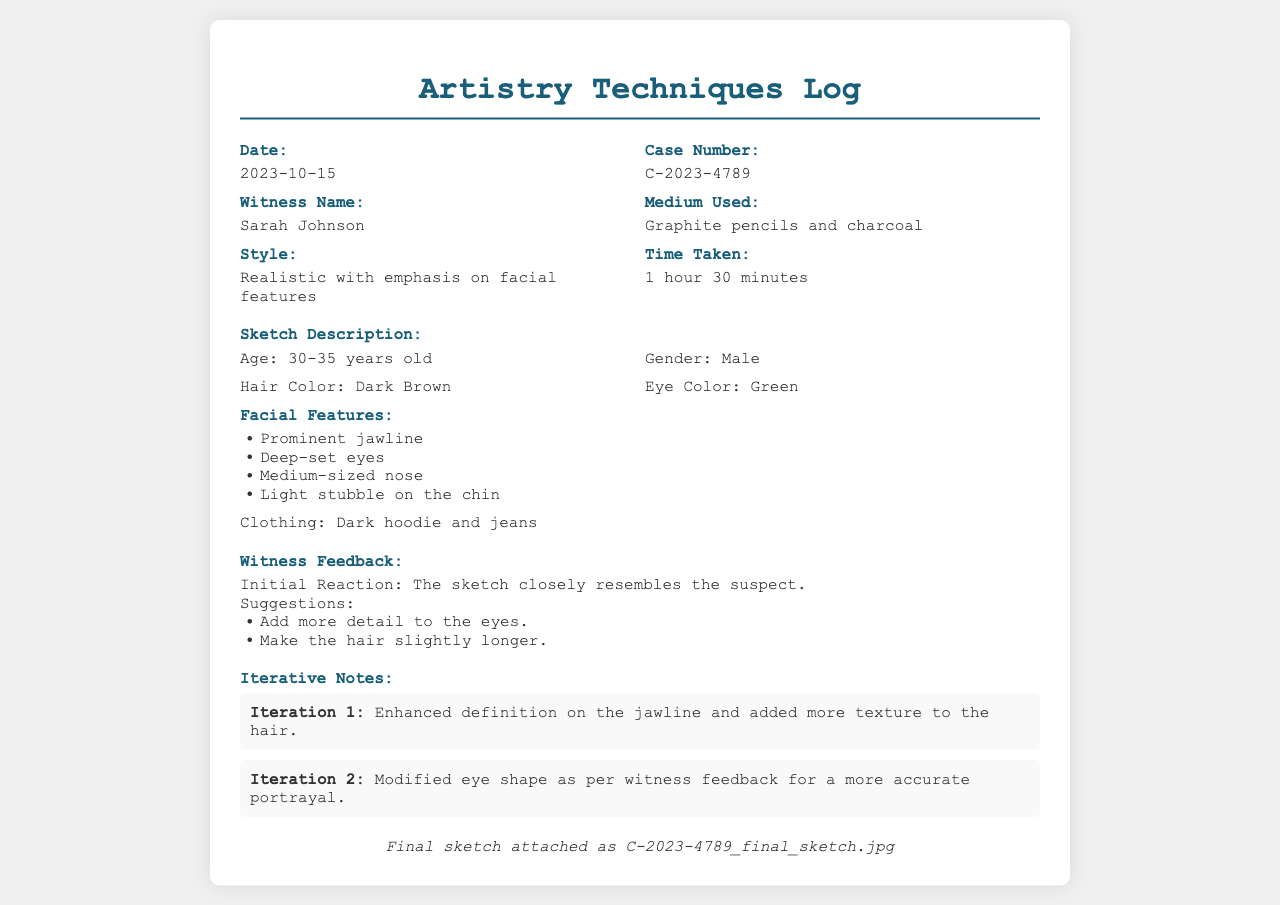What is the date of the sketch? The date is mentioned at the top of the document under "Date."
Answer: 2023-10-15 Who is the witness? The witness's name is provided in the section titled "Witness Name."
Answer: Sarah Johnson What medium was used for the sketch? The medium is listed in the "Medium Used" section.
Answer: Graphite pencils and charcoal How many minutes did it take to create the sketch? The time taken is noted in the "Time Taken" section.
Answer: 90 minutes What is the age range of the suspect? The age range is described in the sketch description.
Answer: 30-35 years old What clothing is the suspect wearing? The clothing description is provided at the end of the sketch description.
Answer: Dark hoodie and jeans What was the initial reaction of the witness? The initial reaction is indicated in the "Witness Feedback" section.
Answer: The sketch closely resembles the suspect What suggestion was made regarding the hair? The suggestion is mentioned under "Suggestions" in the "Witness Feedback" section.
Answer: Make the hair slightly longer What was the focus of Iteration 1? The changes made in Iteration 1 are detailed in the "Iterative Notes" section.
Answer: Enhanced definition on the jawline and added more texture to the hair 